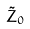<formula> <loc_0><loc_0><loc_500><loc_500>\tilde { Z } _ { 0 }</formula> 